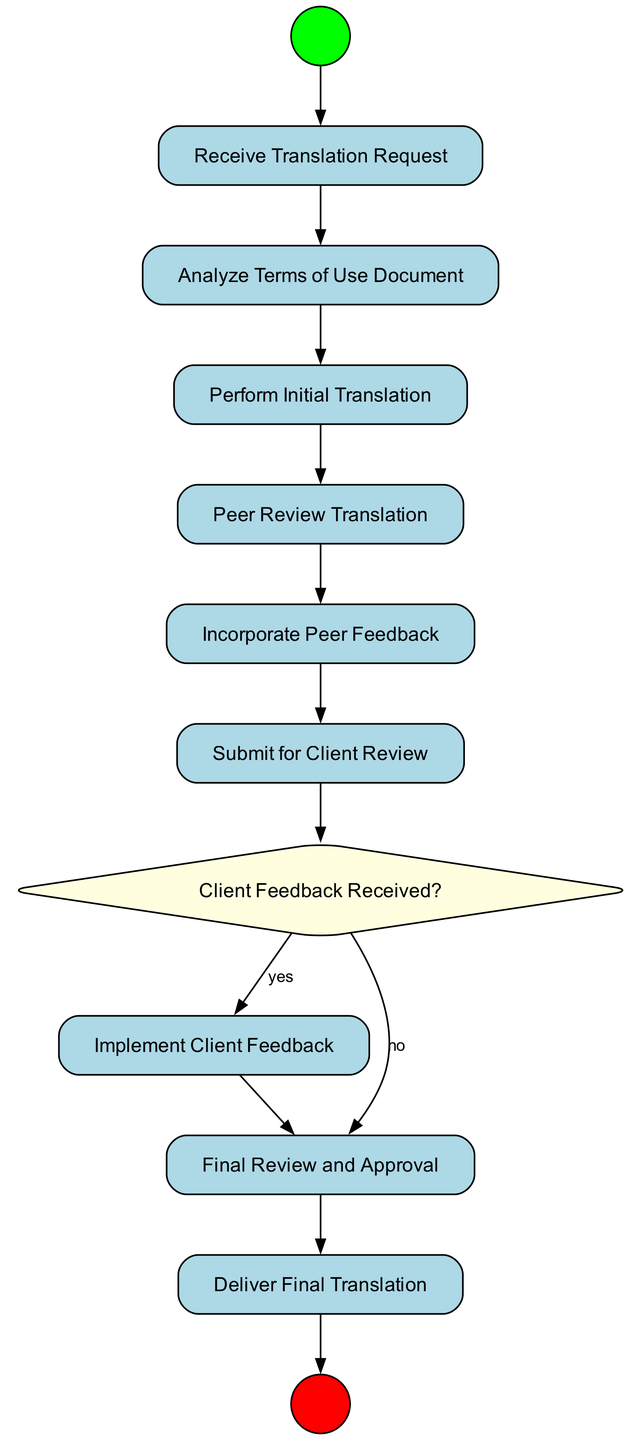What is the first step in the activity diagram? The first step in the activity diagram is represented by the "Start" node, which indicates the beginning of the process.
Answer: Start How many activities are there in the diagram? There are a total of six activities included in the diagram, which are represented as nodes connecting the various steps of the process.
Answer: 6 What action follows "Incorporate Peer Feedback"? The action that follows "Incorporate Peer Feedback" is "Submit for Client Review." This indicates that after incorporating feedback, the translated document is submitted for the client's review.
Answer: Submit for Client Review What decision point is present in the diagram? The decision point present in the diagram is "Client Feedback Received?" which determines the next steps based on whether client feedback has been received.
Answer: Client Feedback Received? How many nodes are there in total? The total number of nodes in the diagram is thirteen, including the start, end, activities, and decision nodes, as well as the transitions connecting them.
Answer: 13 What happens if the answer to "Client Feedback Received?" is no? If the answer to "Client Feedback Received?" is no, the next step is "Final Review and Approval," indicating that the document proceeds to the final checks without needing further client input.
Answer: Final Review and Approval Which activity comes before "Final Review and Approval"? The activity that comes before "Final Review and Approval" depends on whether feedback was implemented or directly submitted for review. If no feedback is expected, it follows from "Client Review" directly; if feedback was given, it follows "Implement Client Feedback."
Answer: Client Review or Implement Client Feedback What is the last action in the process? The last action in the process is "Deliver Final Translation," which completes the workflow by providing the completed translation to the client.
Answer: Deliver Final Translation 